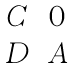Convert formula to latex. <formula><loc_0><loc_0><loc_500><loc_500>\begin{matrix} C & 0 \\ D & A \end{matrix}</formula> 